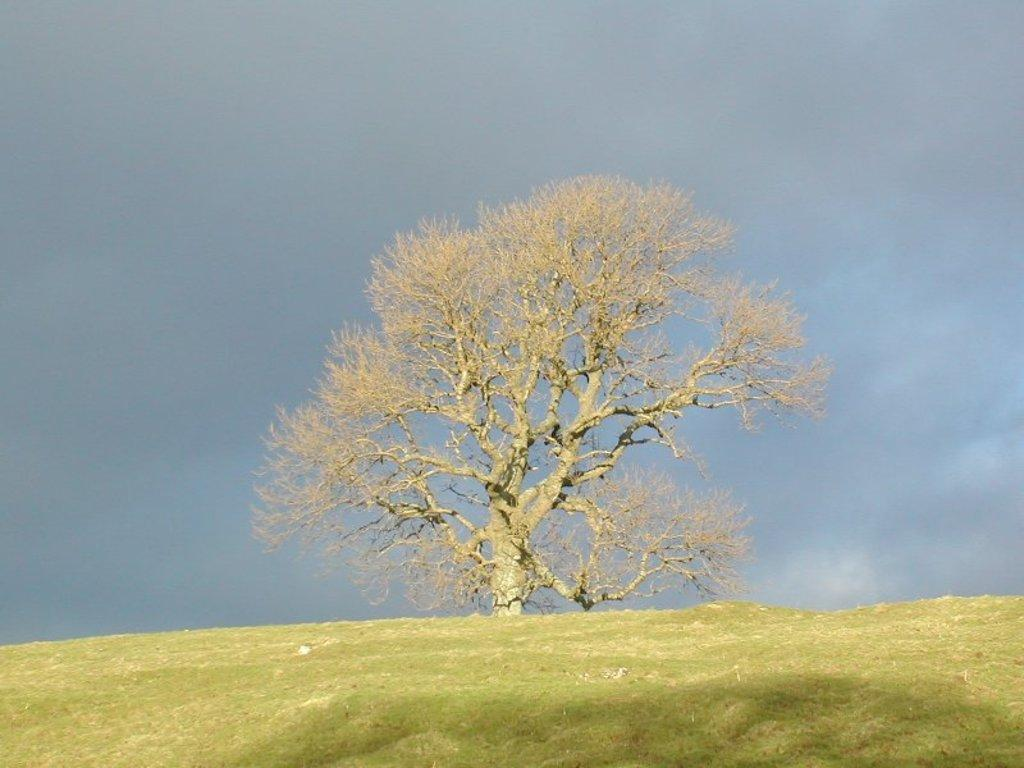What is the main subject in the center of the image? There is a tree in the center of the image. What can be seen in the background of the image? The sky is visible in the background of the image. What type of bell can be heard ringing in the image? There is no bell present in the image, and therefore no sound can be heard. 